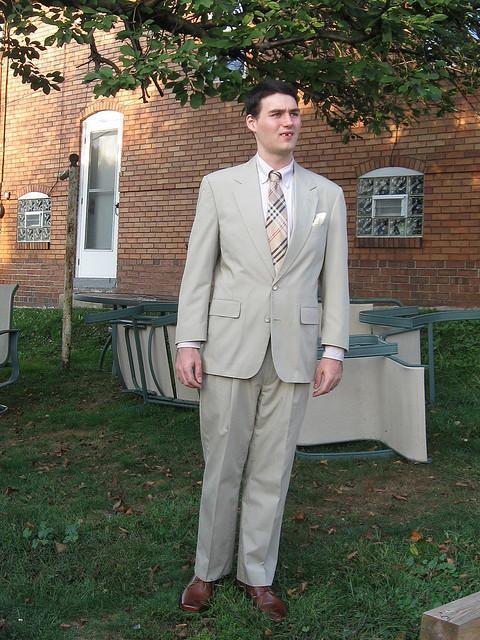How many chairs are there?
Give a very brief answer. 2. How many people are in the picture?
Give a very brief answer. 1. 